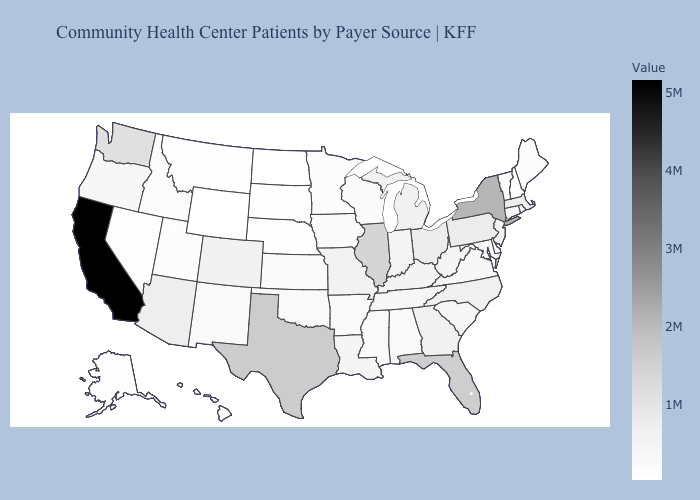Which states hav the highest value in the Northeast?
Be succinct. New York. Which states have the lowest value in the Northeast?
Give a very brief answer. New Hampshire. Among the states that border Nebraska , which have the lowest value?
Keep it brief. Wyoming. Does Illinois have the highest value in the MidWest?
Keep it brief. Yes. Does California have the highest value in the USA?
Concise answer only. Yes. 